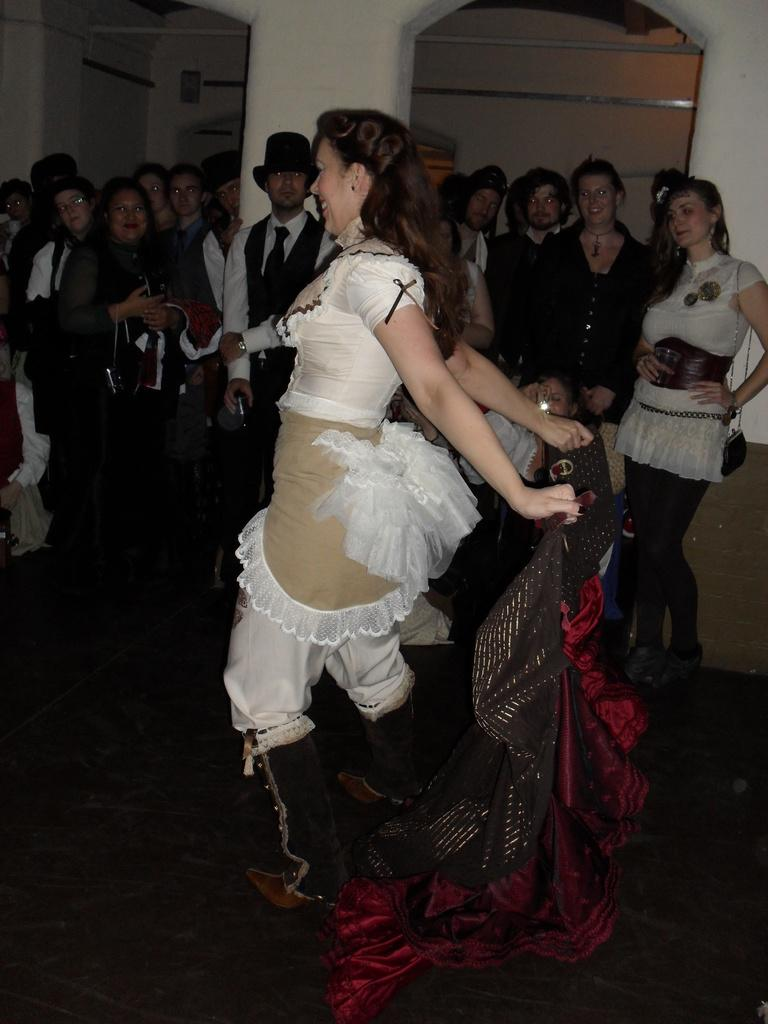What types of people are present in the image? There are men and women in the image. Where are the men and women located? The men and women are standing on the floor. Can you describe the expressions of some of the people in the image? Some of the men and women are smiling. What type of arch can be seen in the background of the image? There is no arch present in the image. What holiday is being celebrated in the image? There is no indication of a holiday being celebrated in the image. 